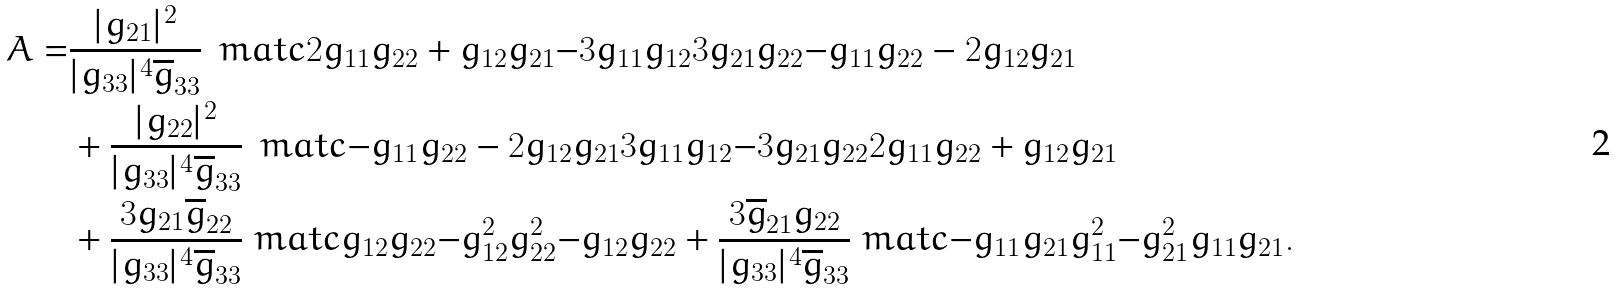Convert formula to latex. <formula><loc_0><loc_0><loc_500><loc_500>A = & \frac { | g _ { 2 1 } | ^ { 2 } } { | g _ { 3 3 } | ^ { 4 } \overline { g } _ { 3 3 } } \, \ m a t c { 2 g _ { 1 1 } g _ { 2 2 } + g _ { 1 2 } g _ { 2 1 } } { - 3 g _ { 1 1 } g _ { 1 2 } } { 3 g _ { 2 1 } g _ { 2 2 } } { - g _ { 1 1 } g _ { 2 2 } - 2 g _ { 1 2 } g _ { 2 1 } } \\ & + \frac { | g _ { 2 2 } | ^ { 2 } } { | g _ { 3 3 } | ^ { 4 } \overline { g } _ { 3 3 } } \, \ m a t c { - g _ { 1 1 } g _ { 2 2 } - 2 g _ { 1 2 } g _ { 2 1 } } { 3 g _ { 1 1 } g _ { 1 2 } } { - 3 g _ { 2 1 } g _ { 2 2 } } { 2 g _ { 1 1 } g _ { 2 2 } + g _ { 1 2 } g _ { 2 1 } } \\ & + \frac { 3 g _ { 2 1 } \overline { g } _ { 2 2 } } { | g _ { 3 3 } | ^ { 4 } \overline { g } _ { 3 3 } } \ m a t c { g _ { 1 2 } g _ { 2 2 } } { - g _ { 1 2 } ^ { 2 } } { g _ { 2 2 } ^ { 2 } } { - g _ { 1 2 } g _ { 2 2 } } + \frac { 3 \overline { g } _ { 2 1 } g _ { 2 2 } } { | g _ { 3 3 } | ^ { 4 } \overline { g } _ { 3 3 } } \ m a t c { - g _ { 1 1 } g _ { 2 1 } } { g _ { 1 1 } ^ { 2 } } { - g _ { 2 1 } ^ { 2 } } { g _ { 1 1 } g _ { 2 1 } } .</formula> 